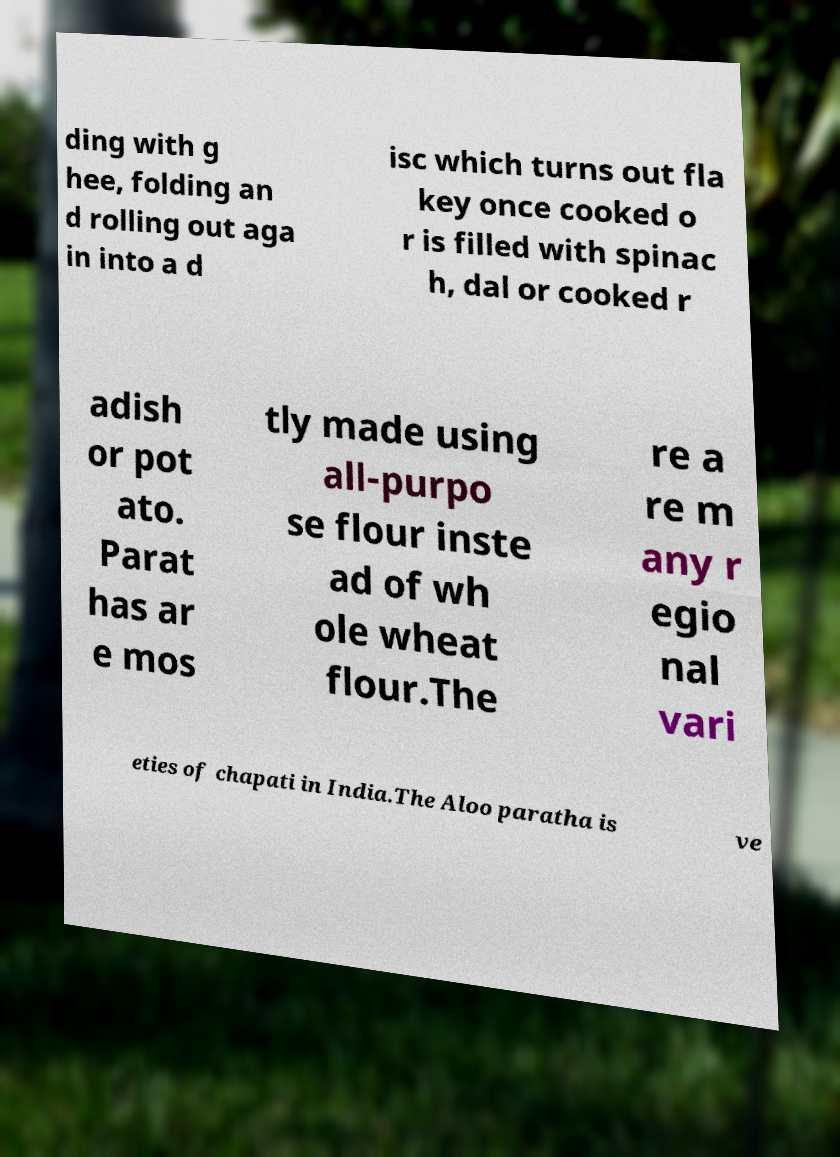Can you read and provide the text displayed in the image?This photo seems to have some interesting text. Can you extract and type it out for me? ding with g hee, folding an d rolling out aga in into a d isc which turns out fla key once cooked o r is filled with spinac h, dal or cooked r adish or pot ato. Parat has ar e mos tly made using all-purpo se flour inste ad of wh ole wheat flour.The re a re m any r egio nal vari eties of chapati in India.The Aloo paratha is ve 